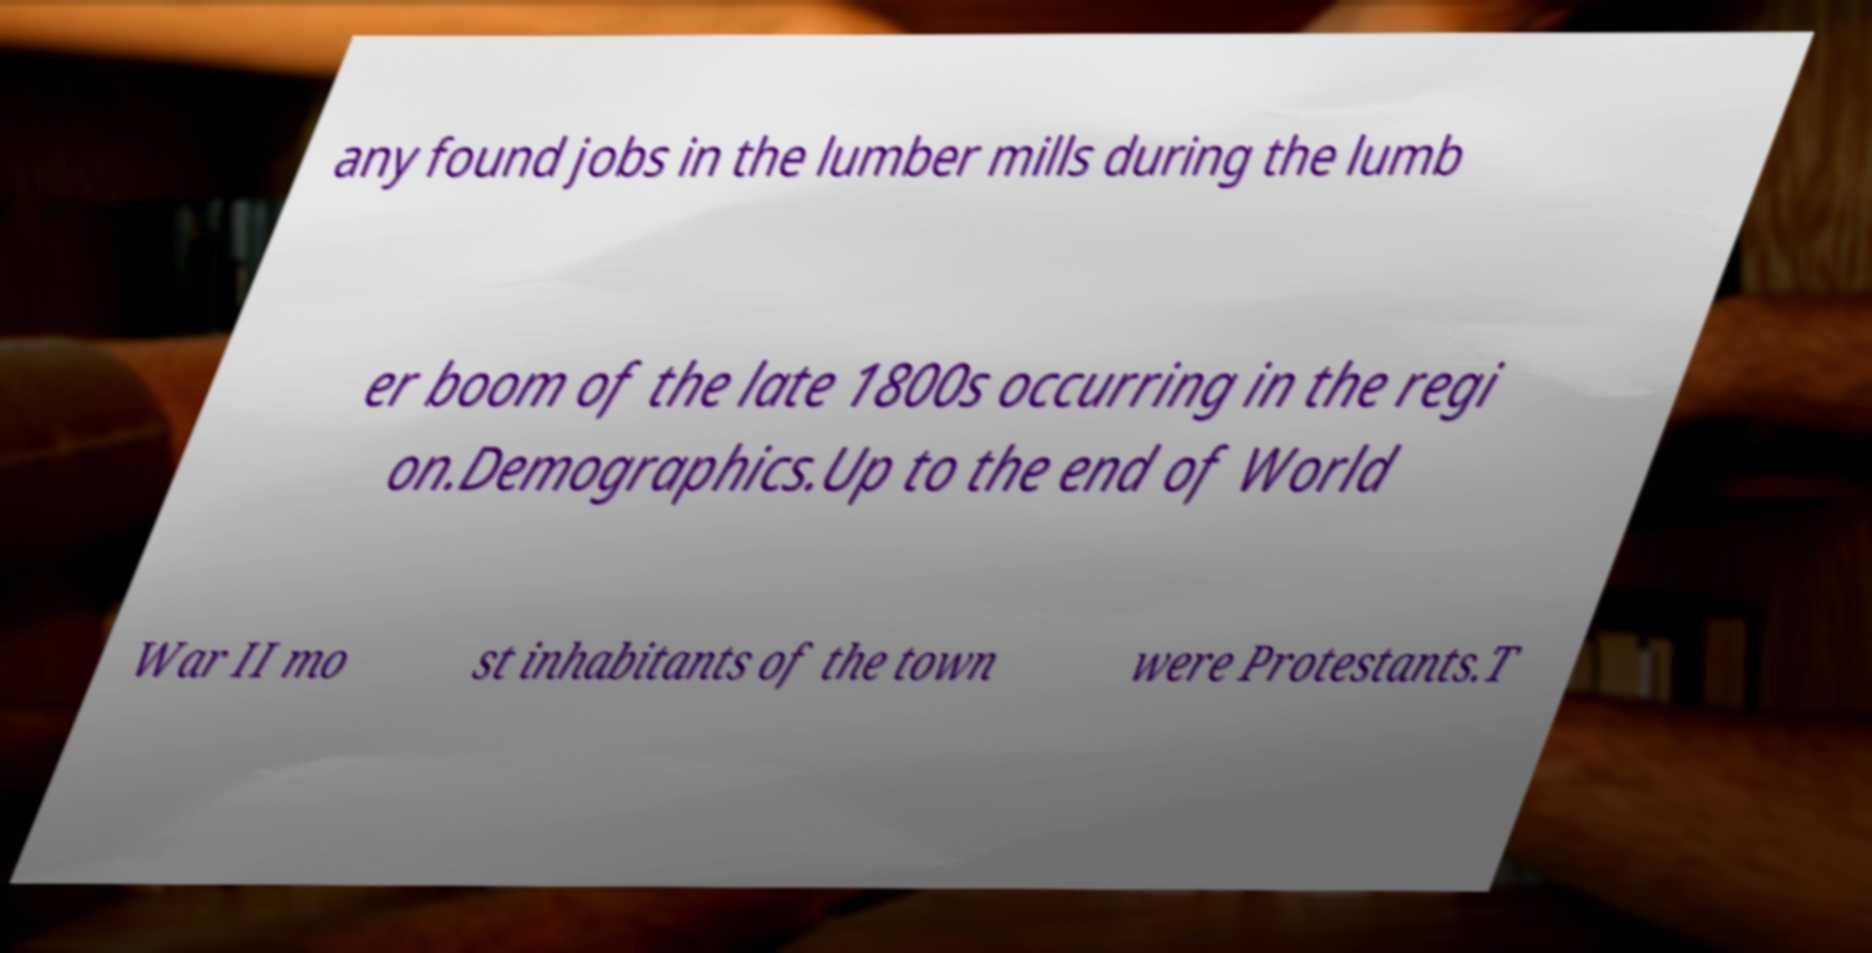Can you read and provide the text displayed in the image?This photo seems to have some interesting text. Can you extract and type it out for me? any found jobs in the lumber mills during the lumb er boom of the late 1800s occurring in the regi on.Demographics.Up to the end of World War II mo st inhabitants of the town were Protestants.T 